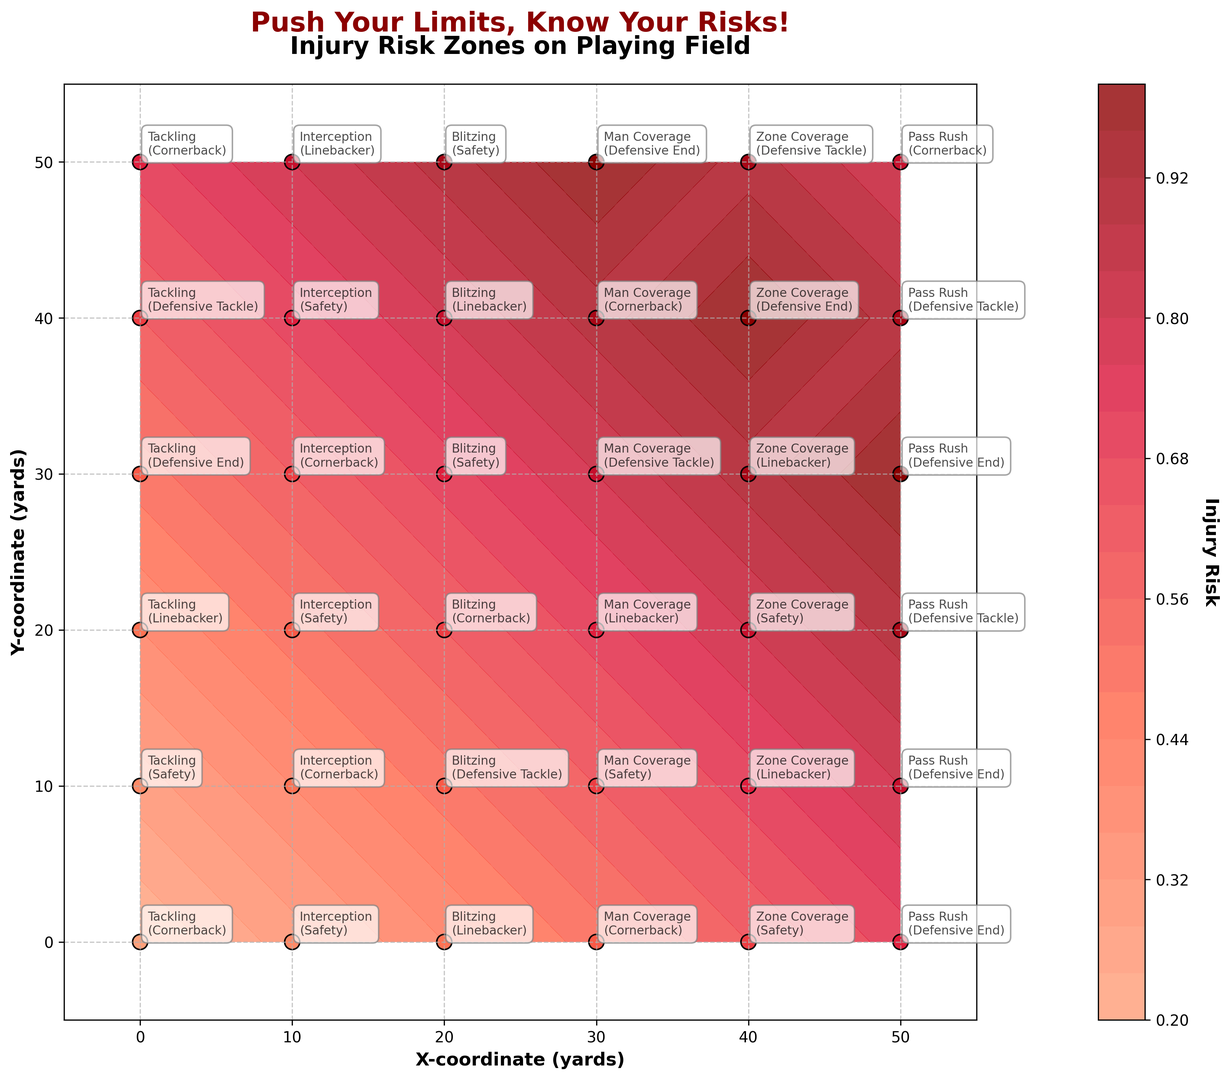what is the injury risk at coordinates (30, 30)? To find the injury risk at coordinates (30, 30), locate the point (30, 30) on the plot. The color intensity and the annotated value at this point show the injury risk. Here, the value is 0.8.
Answer: 0.8 Which maneuver is associated with the highest injury risk? To answer this, we need to identify the point on the plot with the darkest color indicating the highest injury risk and check the corresponding maneuver annotation. The darkest color indicates an injury risk of 1.0, associated with "Man Coverage" at position (30, 50).
Answer: Man Coverage What is the average injury risk for Tackling maneuvers across different positions? Collect the injury risk values for all "Tackling" maneuvers from the plot: 0.2, 0.3, 0.4, 0.5, 0.6, 0.7. Calculate the average: (0.2 + 0.3 + 0.4 + 0.5 + 0.6 + 0.7) / 6 = 2.7 / 6 = 0.45.
Answer: 0.45 Is the injury risk higher for "Man Coverage" or "Zone Coverage" maneuvers? Compare the injury risk values for "Man Coverage" (0.5, 0.6, 0.7, 0.8, 0.9, 1.0) with those for "Zone Coverage" (0.6, 0.7, 0.8, 0.9, 1.0, 0.9). Both have maximum values of 1.0, but "Man Coverage" reaches 1.0 at coordinates (30, 50).
Answer: Man Coverage Which player position is associated with the highest injury risk? Locate the coordinates with the highest injury risk value of 1.0, noting the player position annotations. Both "Man Coverage" at (30, 50) and "Zone Coverage" at (40, 40) indicate "Defensive End" at maximum injury risk of 1.0.
Answer: Defensive End What is the injury risk difference between coordinates (50, 30) and (0, 0)? Determine injury risks at (50, 30) as 1.0 and at (0, 0) as 0.2. Calculate the difference: 1.0 - 0.2.
Answer: 0.8 How does the injury risk for "Blitzing" vary across positions? Identify injury risk values for "Blitzing" at different positions: 0.4, 0.5, 0.6, 0.7, 0.8, 0.9. These values show an increasing trend in injury risk from one position to another.
Answer: Increases Which coordinate has the lowest injury risk, and what position is associated with it? Find the coordinates with the lightest color and smallest annotated injury risk value of 0.2. The position at (0, 0) has the lowest injury risk and is associated with "Cornerback".
Answer: (0, 0), Cornerback 